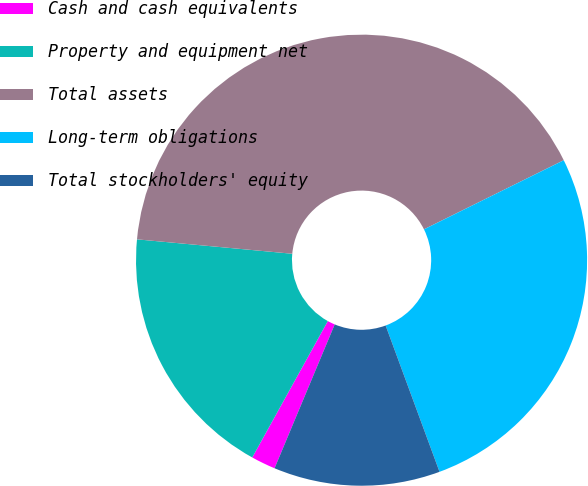<chart> <loc_0><loc_0><loc_500><loc_500><pie_chart><fcel>Cash and cash equivalents<fcel>Property and equipment net<fcel>Total assets<fcel>Long-term obligations<fcel>Total stockholders' equity<nl><fcel>1.75%<fcel>18.42%<fcel>41.22%<fcel>26.69%<fcel>11.92%<nl></chart> 